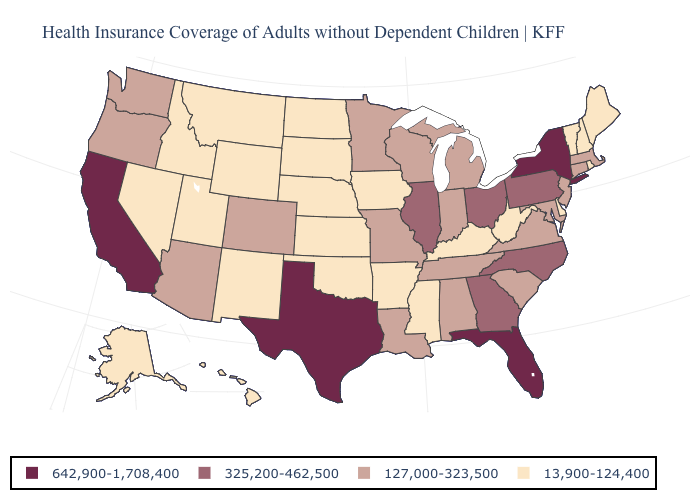Does the map have missing data?
Quick response, please. No. How many symbols are there in the legend?
Keep it brief. 4. Which states have the lowest value in the USA?
Be succinct. Alaska, Arkansas, Delaware, Hawaii, Idaho, Iowa, Kansas, Kentucky, Maine, Mississippi, Montana, Nebraska, Nevada, New Hampshire, New Mexico, North Dakota, Oklahoma, Rhode Island, South Dakota, Utah, Vermont, West Virginia, Wyoming. Does South Dakota have the lowest value in the USA?
Write a very short answer. Yes. Does the map have missing data?
Give a very brief answer. No. Name the states that have a value in the range 13,900-124,400?
Short answer required. Alaska, Arkansas, Delaware, Hawaii, Idaho, Iowa, Kansas, Kentucky, Maine, Mississippi, Montana, Nebraska, Nevada, New Hampshire, New Mexico, North Dakota, Oklahoma, Rhode Island, South Dakota, Utah, Vermont, West Virginia, Wyoming. Among the states that border South Carolina , which have the highest value?
Be succinct. Georgia, North Carolina. What is the value of South Dakota?
Be succinct. 13,900-124,400. What is the value of Missouri?
Keep it brief. 127,000-323,500. Which states have the lowest value in the MidWest?
Answer briefly. Iowa, Kansas, Nebraska, North Dakota, South Dakota. Does Mississippi have the lowest value in the USA?
Write a very short answer. Yes. What is the value of Mississippi?
Write a very short answer. 13,900-124,400. Is the legend a continuous bar?
Quick response, please. No. Among the states that border Iowa , does Minnesota have the lowest value?
Keep it brief. No. Which states have the highest value in the USA?
Quick response, please. California, Florida, New York, Texas. 